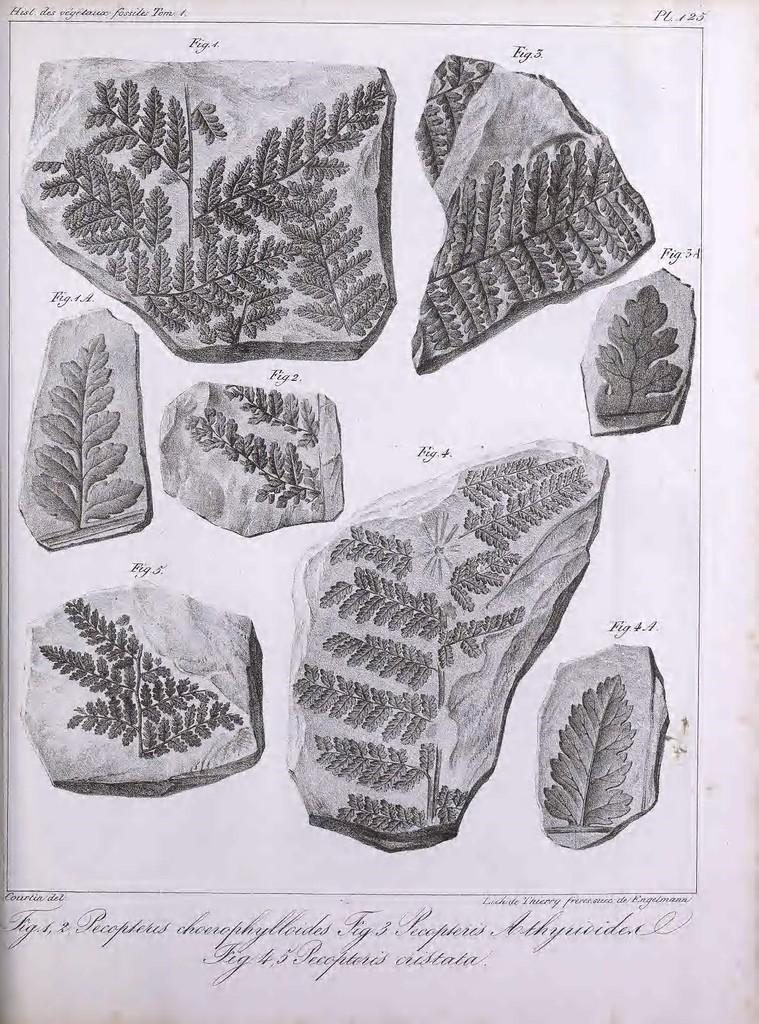What is the main subject of the image? There is a picture in the image. What elements are included in the picture? The picture contains rocks and leaves. What is the picture drawn or printed on? The picture is on a paper. How much dirt is visible on the rocks in the image? There is no dirt visible on the rocks in the image, as the facts provided do not mention any dirt. 